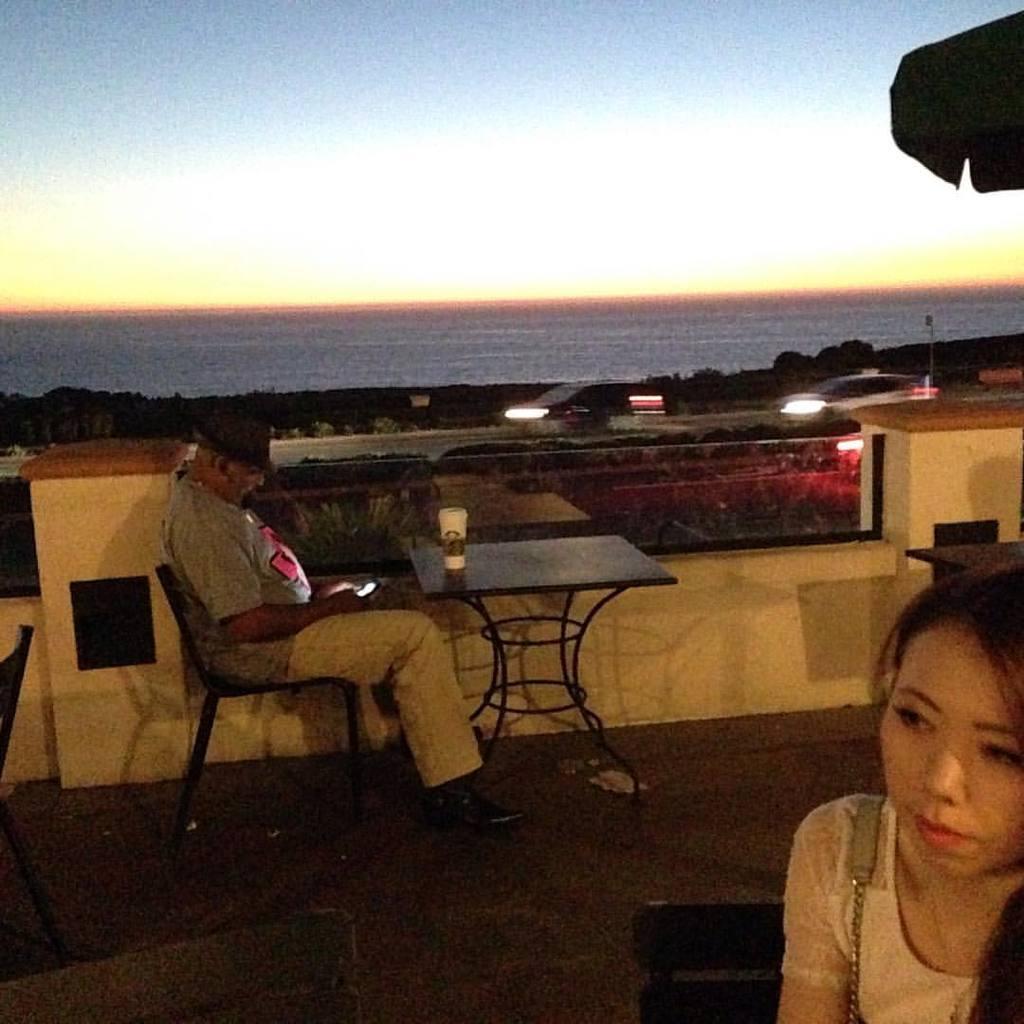In one or two sentences, can you explain what this image depicts? We can see in the image that a man sitting on a chair a table is in front of him. There is a road beside him and a sea. 